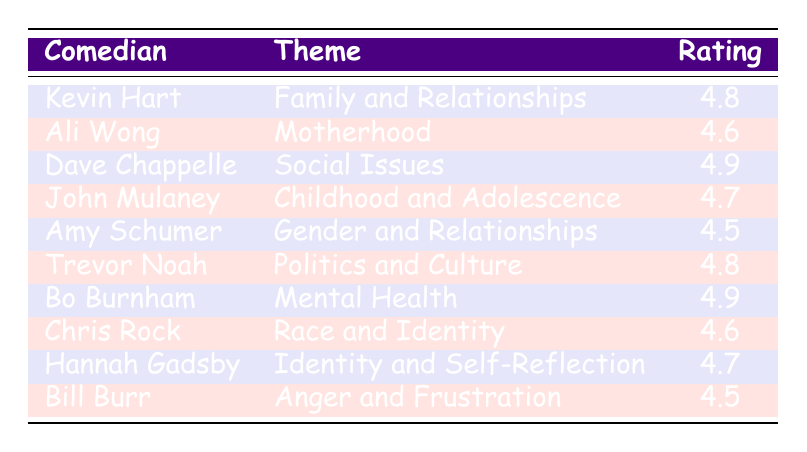What is the audience rating for Dave Chappelle's theme? The table shows that Dave Chappelle has a rating of 4.9 listed under the "Social Issues" theme.
Answer: 4.9 Who has a higher audience rating, Kevin Hart or Ali Wong? Kevin Hart's rating is 4.8 while Ali Wong's rating is 4.6. Therefore, Kevin Hart has a higher rating.
Answer: Kevin Hart What is the theme of John Mulaney’s stand-up? The table indicates that John Mulaney's theme is "Childhood and Adolescence."
Answer: Childhood and Adolescence Is the audience rating for Mental Health higher than that for Gender and Relationships? Bo Burnham's rating for Mental Health is 4.9, while Amy Schumer’s rating for Gender and Relationships is 4.5. Since 4.9 is greater than 4.5, the statement is true.
Answer: Yes What is the average audience rating of the comedians focusing on personal experiences (Family, Motherhood, and Mental Health)? The ratings for Kevin Hart (4.8), Ali Wong (4.6), and Bo Burnham (4.9) are summed: 4.8 + 4.6 + 4.9 = 14.3. There are 3 data points, so the average is 14.3 / 3 = 4.77.
Answer: 4.77 Are there any comedians with a rating of 4.5? Yes, both Amy Schumer and Bill Burr have ratings of 4.5, as indicated in the table.
Answer: Yes What is the difference in audience ratings between Chris Rock and Hannah Gadsby? Chris Rock has a rating of 4.6 and Hannah Gadsby has 4.7. The difference is 4.7 - 4.6 = 0.1.
Answer: 0.1 Which comedian's routine on Politics and Culture has an audience rating equal to or greater than 4.8? Trevor Noah covers the theme "Politics and Culture" and has a rating of 4.8, which meets the criterion of being equal to or greater than 4.8.
Answer: Trevor Noah How many comedians have an audience rating of 4.7 or higher? The comedians with ratings of 4.7 or higher are Kevin Hart (4.8), Dave Chappelle (4.9), John Mulaney (4.7), Bo Burnham (4.9), and Hannah Gadsby (4.7), totaling 5 comedians.
Answer: 5 